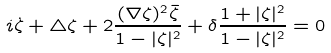<formula> <loc_0><loc_0><loc_500><loc_500>i \dot { \zeta } + \triangle \zeta + 2 \frac { ( \nabla \zeta ) ^ { 2 } \bar { \zeta } } { 1 - | \zeta | ^ { 2 } } + \delta \frac { 1 + | \zeta | ^ { 2 } } { 1 - | \zeta | ^ { 2 } } = 0</formula> 